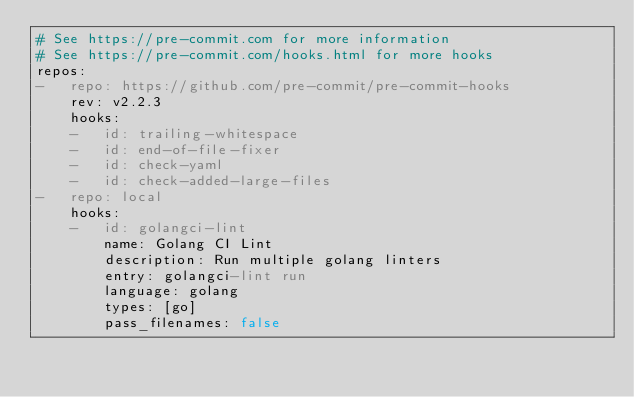Convert code to text. <code><loc_0><loc_0><loc_500><loc_500><_YAML_># See https://pre-commit.com for more information
# See https://pre-commit.com/hooks.html for more hooks
repos:
-   repo: https://github.com/pre-commit/pre-commit-hooks
    rev: v2.2.3
    hooks:
    -   id: trailing-whitespace
    -   id: end-of-file-fixer
    -   id: check-yaml
    -   id: check-added-large-files
-   repo: local
    hooks:
    -   id: golangci-lint
        name: Golang CI Lint
        description: Run multiple golang linters
        entry: golangci-lint run
        language: golang
        types: [go]
        pass_filenames: false
</code> 